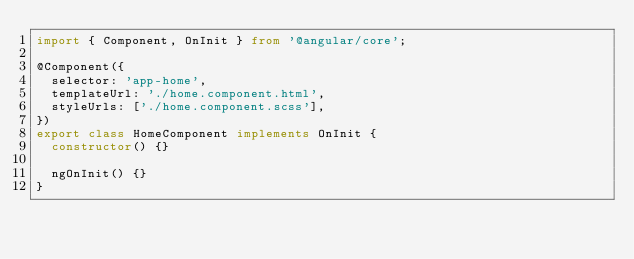Convert code to text. <code><loc_0><loc_0><loc_500><loc_500><_TypeScript_>import { Component, OnInit } from '@angular/core';

@Component({
  selector: 'app-home',
  templateUrl: './home.component.html',
  styleUrls: ['./home.component.scss'],
})
export class HomeComponent implements OnInit {
  constructor() {}

  ngOnInit() {}
}
</code> 